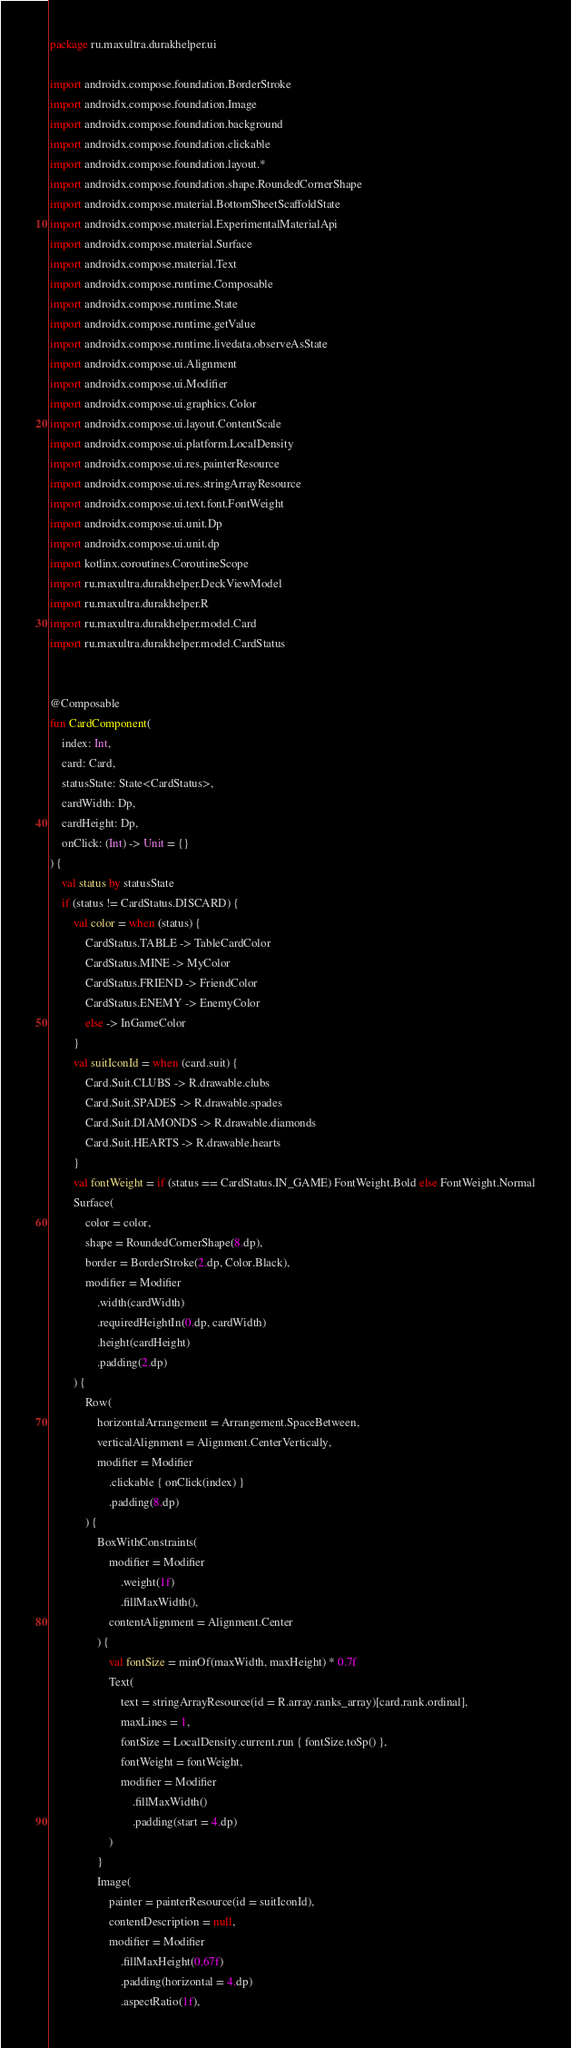Convert code to text. <code><loc_0><loc_0><loc_500><loc_500><_Kotlin_>package ru.maxultra.durakhelper.ui

import androidx.compose.foundation.BorderStroke
import androidx.compose.foundation.Image
import androidx.compose.foundation.background
import androidx.compose.foundation.clickable
import androidx.compose.foundation.layout.*
import androidx.compose.foundation.shape.RoundedCornerShape
import androidx.compose.material.BottomSheetScaffoldState
import androidx.compose.material.ExperimentalMaterialApi
import androidx.compose.material.Surface
import androidx.compose.material.Text
import androidx.compose.runtime.Composable
import androidx.compose.runtime.State
import androidx.compose.runtime.getValue
import androidx.compose.runtime.livedata.observeAsState
import androidx.compose.ui.Alignment
import androidx.compose.ui.Modifier
import androidx.compose.ui.graphics.Color
import androidx.compose.ui.layout.ContentScale
import androidx.compose.ui.platform.LocalDensity
import androidx.compose.ui.res.painterResource
import androidx.compose.ui.res.stringArrayResource
import androidx.compose.ui.text.font.FontWeight
import androidx.compose.ui.unit.Dp
import androidx.compose.ui.unit.dp
import kotlinx.coroutines.CoroutineScope
import ru.maxultra.durakhelper.DeckViewModel
import ru.maxultra.durakhelper.R
import ru.maxultra.durakhelper.model.Card
import ru.maxultra.durakhelper.model.CardStatus


@Composable
fun CardComponent(
    index: Int,
    card: Card,
    statusState: State<CardStatus>,
    cardWidth: Dp,
    cardHeight: Dp,
    onClick: (Int) -> Unit = {}
) {
    val status by statusState
    if (status != CardStatus.DISCARD) {
        val color = when (status) {
            CardStatus.TABLE -> TableCardColor
            CardStatus.MINE -> MyColor
            CardStatus.FRIEND -> FriendColor
            CardStatus.ENEMY -> EnemyColor
            else -> InGameColor
        }
        val suitIconId = when (card.suit) {
            Card.Suit.CLUBS -> R.drawable.clubs
            Card.Suit.SPADES -> R.drawable.spades
            Card.Suit.DIAMONDS -> R.drawable.diamonds
            Card.Suit.HEARTS -> R.drawable.hearts
        }
        val fontWeight = if (status == CardStatus.IN_GAME) FontWeight.Bold else FontWeight.Normal
        Surface(
            color = color,
            shape = RoundedCornerShape(8.dp),
            border = BorderStroke(2.dp, Color.Black),
            modifier = Modifier
                .width(cardWidth)
                .requiredHeightIn(0.dp, cardWidth)
                .height(cardHeight)
                .padding(2.dp)
        ) {
            Row(
                horizontalArrangement = Arrangement.SpaceBetween,
                verticalAlignment = Alignment.CenterVertically,
                modifier = Modifier
                    .clickable { onClick(index) }
                    .padding(8.dp)
            ) {
                BoxWithConstraints(
                    modifier = Modifier
                        .weight(1f)
                        .fillMaxWidth(),
                    contentAlignment = Alignment.Center
                ) {
                    val fontSize = minOf(maxWidth, maxHeight) * 0.7f
                    Text(
                        text = stringArrayResource(id = R.array.ranks_array)[card.rank.ordinal],
                        maxLines = 1,
                        fontSize = LocalDensity.current.run { fontSize.toSp() },
                        fontWeight = fontWeight,
                        modifier = Modifier
                            .fillMaxWidth()
                            .padding(start = 4.dp)
                    )
                }
                Image(
                    painter = painterResource(id = suitIconId),
                    contentDescription = null,
                    modifier = Modifier
                        .fillMaxHeight(0.67f)
                        .padding(horizontal = 4.dp)
                        .aspectRatio(1f),</code> 